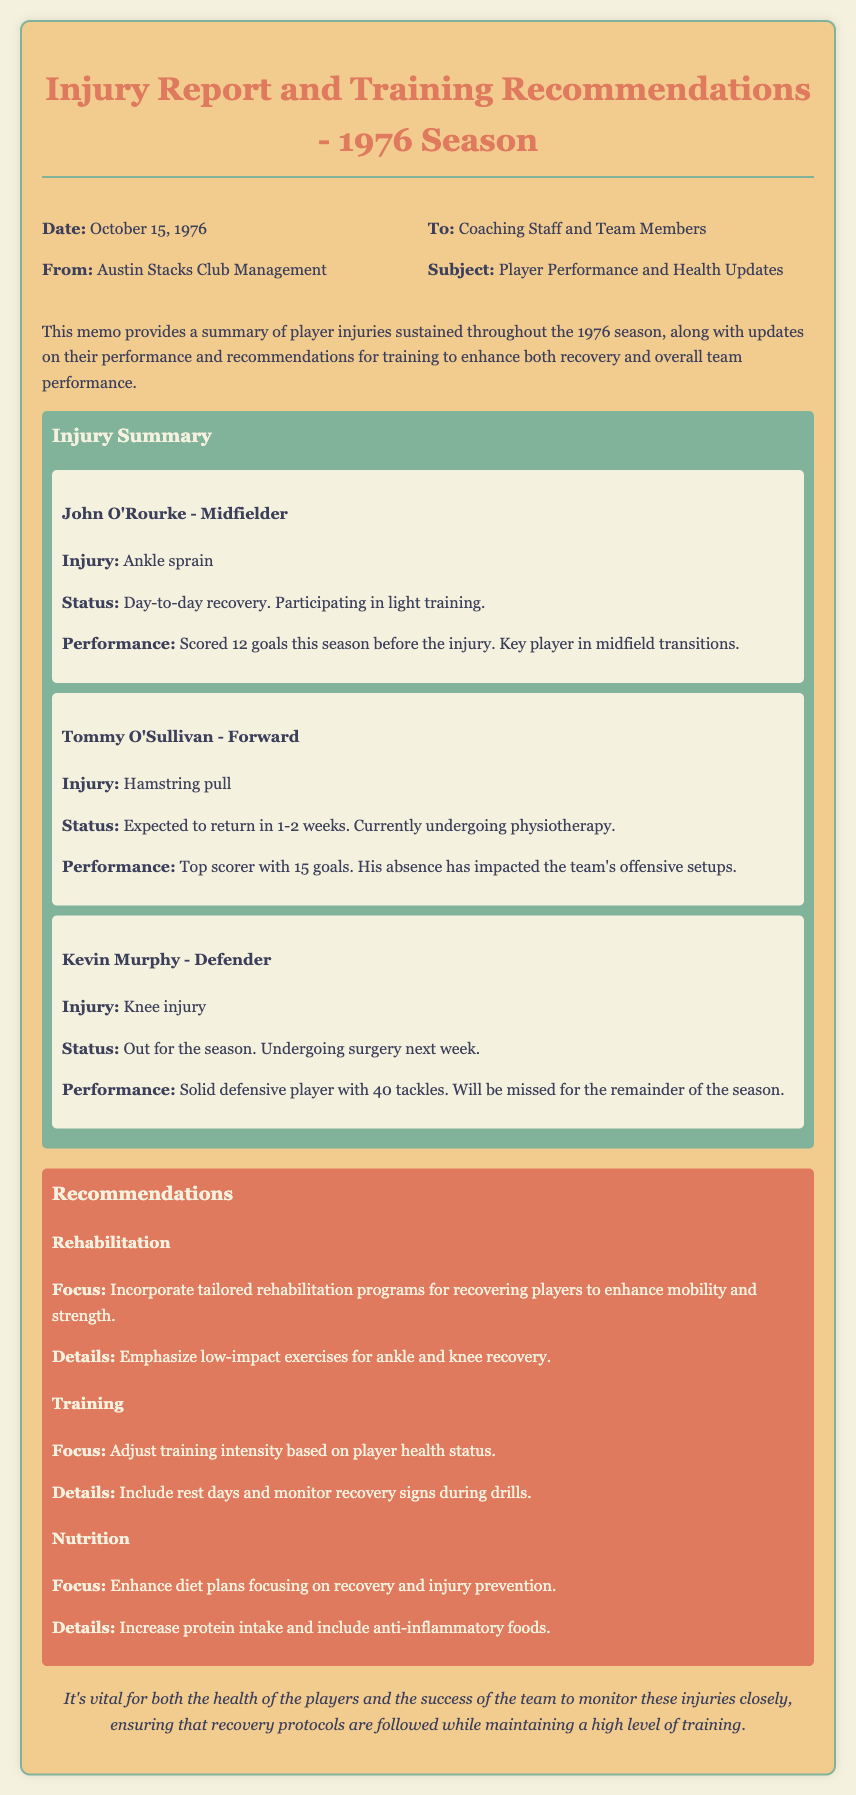What is the date of the memo? The date of the memo is listed in the header section, which states October 15, 1976.
Answer: October 15, 1976 Who is the top scorer this season? The top scorer's name is found in the injury summary under Tommy O'Sullivan's details, who has the most goals scored.
Answer: Tommy O'Sullivan What type of injury does Kevin Murphy have? The type of injury for Kevin Murphy is specified in his injury summary section of the document.
Answer: Knee injury What is John O'Rourke's current recovery status? John's recovery status is stated as day-to-day, found in the injury summary section.
Answer: Day-to-day recovery How many tackles did Kevin Murphy have this season? The number of tackles is provided in Kevin Murphy's performance details in the injury summary section.
Answer: 40 tackles What is the recommended focus for rehabilitation? The document outlines the specific focus areas for rehabilitation programs under the recommendations section.
Answer: Tailored rehabilitation programs How many goals did John O'Rourke score this season? The total number of goals scored by John O'Rourke before his injury is stated in his performance details.
Answer: 12 goals What is emphasized for nutritional improvement? The recommendations section provides details on what should be enhanced in the players' diet for recovery.
Answer: Increase protein intake What is the focus during training for recovering players? The specific focus during training for players recovering from injuries is noted in the recommendations section.
Answer: Adjust training intensity 